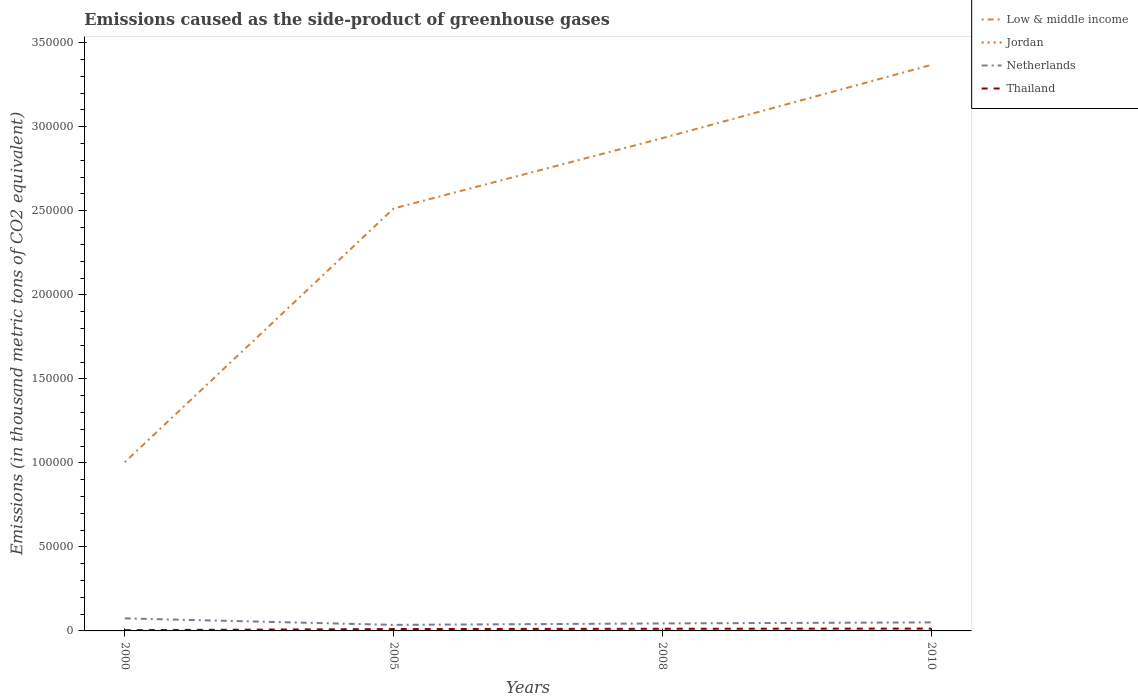Does the line corresponding to Jordan intersect with the line corresponding to Low & middle income?
Your answer should be very brief. No. Is the number of lines equal to the number of legend labels?
Provide a short and direct response. Yes. Across all years, what is the maximum emissions caused as the side-product of greenhouse gases in Low & middle income?
Your response must be concise. 1.00e+05. In which year was the emissions caused as the side-product of greenhouse gases in Netherlands maximum?
Your response must be concise. 2005. What is the total emissions caused as the side-product of greenhouse gases in Netherlands in the graph?
Offer a terse response. 3865.1. What is the difference between the highest and the second highest emissions caused as the side-product of greenhouse gases in Jordan?
Provide a short and direct response. 173.3. What is the difference between the highest and the lowest emissions caused as the side-product of greenhouse gases in Thailand?
Provide a succinct answer. 3. How many lines are there?
Keep it short and to the point. 4. What is the difference between two consecutive major ticks on the Y-axis?
Provide a short and direct response. 5.00e+04. Does the graph contain grids?
Your answer should be very brief. No. Where does the legend appear in the graph?
Ensure brevity in your answer.  Top right. How many legend labels are there?
Ensure brevity in your answer.  4. How are the legend labels stacked?
Keep it short and to the point. Vertical. What is the title of the graph?
Offer a very short reply. Emissions caused as the side-product of greenhouse gases. What is the label or title of the Y-axis?
Keep it short and to the point. Emissions (in thousand metric tons of CO2 equivalent). What is the Emissions (in thousand metric tons of CO2 equivalent) of Low & middle income in 2000?
Provide a short and direct response. 1.00e+05. What is the Emissions (in thousand metric tons of CO2 equivalent) in Netherlands in 2000?
Your answer should be very brief. 7462.9. What is the Emissions (in thousand metric tons of CO2 equivalent) in Thailand in 2000?
Your answer should be very brief. 453.1. What is the Emissions (in thousand metric tons of CO2 equivalent) of Low & middle income in 2005?
Provide a succinct answer. 2.51e+05. What is the Emissions (in thousand metric tons of CO2 equivalent) in Jordan in 2005?
Your answer should be compact. 110.3. What is the Emissions (in thousand metric tons of CO2 equivalent) of Netherlands in 2005?
Your response must be concise. 3597.8. What is the Emissions (in thousand metric tons of CO2 equivalent) of Thailand in 2005?
Your response must be concise. 1103.9. What is the Emissions (in thousand metric tons of CO2 equivalent) of Low & middle income in 2008?
Provide a short and direct response. 2.93e+05. What is the Emissions (in thousand metric tons of CO2 equivalent) of Jordan in 2008?
Your answer should be compact. 158.8. What is the Emissions (in thousand metric tons of CO2 equivalent) in Netherlands in 2008?
Provide a succinct answer. 4459.4. What is the Emissions (in thousand metric tons of CO2 equivalent) of Thailand in 2008?
Offer a terse response. 1274.5. What is the Emissions (in thousand metric tons of CO2 equivalent) in Low & middle income in 2010?
Offer a very short reply. 3.37e+05. What is the Emissions (in thousand metric tons of CO2 equivalent) of Jordan in 2010?
Provide a short and direct response. 193. What is the Emissions (in thousand metric tons of CO2 equivalent) of Netherlands in 2010?
Offer a terse response. 5074. What is the Emissions (in thousand metric tons of CO2 equivalent) in Thailand in 2010?
Make the answer very short. 1388. Across all years, what is the maximum Emissions (in thousand metric tons of CO2 equivalent) of Low & middle income?
Ensure brevity in your answer.  3.37e+05. Across all years, what is the maximum Emissions (in thousand metric tons of CO2 equivalent) in Jordan?
Give a very brief answer. 193. Across all years, what is the maximum Emissions (in thousand metric tons of CO2 equivalent) of Netherlands?
Offer a terse response. 7462.9. Across all years, what is the maximum Emissions (in thousand metric tons of CO2 equivalent) in Thailand?
Ensure brevity in your answer.  1388. Across all years, what is the minimum Emissions (in thousand metric tons of CO2 equivalent) in Low & middle income?
Your answer should be compact. 1.00e+05. Across all years, what is the minimum Emissions (in thousand metric tons of CO2 equivalent) in Netherlands?
Your answer should be compact. 3597.8. Across all years, what is the minimum Emissions (in thousand metric tons of CO2 equivalent) in Thailand?
Offer a very short reply. 453.1. What is the total Emissions (in thousand metric tons of CO2 equivalent) in Low & middle income in the graph?
Keep it short and to the point. 9.82e+05. What is the total Emissions (in thousand metric tons of CO2 equivalent) in Jordan in the graph?
Your answer should be very brief. 481.8. What is the total Emissions (in thousand metric tons of CO2 equivalent) in Netherlands in the graph?
Make the answer very short. 2.06e+04. What is the total Emissions (in thousand metric tons of CO2 equivalent) of Thailand in the graph?
Your answer should be very brief. 4219.5. What is the difference between the Emissions (in thousand metric tons of CO2 equivalent) in Low & middle income in 2000 and that in 2005?
Ensure brevity in your answer.  -1.51e+05. What is the difference between the Emissions (in thousand metric tons of CO2 equivalent) of Jordan in 2000 and that in 2005?
Keep it short and to the point. -90.6. What is the difference between the Emissions (in thousand metric tons of CO2 equivalent) in Netherlands in 2000 and that in 2005?
Your answer should be compact. 3865.1. What is the difference between the Emissions (in thousand metric tons of CO2 equivalent) in Thailand in 2000 and that in 2005?
Ensure brevity in your answer.  -650.8. What is the difference between the Emissions (in thousand metric tons of CO2 equivalent) in Low & middle income in 2000 and that in 2008?
Offer a very short reply. -1.93e+05. What is the difference between the Emissions (in thousand metric tons of CO2 equivalent) in Jordan in 2000 and that in 2008?
Offer a terse response. -139.1. What is the difference between the Emissions (in thousand metric tons of CO2 equivalent) in Netherlands in 2000 and that in 2008?
Your answer should be compact. 3003.5. What is the difference between the Emissions (in thousand metric tons of CO2 equivalent) in Thailand in 2000 and that in 2008?
Ensure brevity in your answer.  -821.4. What is the difference between the Emissions (in thousand metric tons of CO2 equivalent) of Low & middle income in 2000 and that in 2010?
Your response must be concise. -2.36e+05. What is the difference between the Emissions (in thousand metric tons of CO2 equivalent) in Jordan in 2000 and that in 2010?
Your answer should be compact. -173.3. What is the difference between the Emissions (in thousand metric tons of CO2 equivalent) in Netherlands in 2000 and that in 2010?
Offer a terse response. 2388.9. What is the difference between the Emissions (in thousand metric tons of CO2 equivalent) in Thailand in 2000 and that in 2010?
Give a very brief answer. -934.9. What is the difference between the Emissions (in thousand metric tons of CO2 equivalent) in Low & middle income in 2005 and that in 2008?
Ensure brevity in your answer.  -4.19e+04. What is the difference between the Emissions (in thousand metric tons of CO2 equivalent) in Jordan in 2005 and that in 2008?
Your answer should be very brief. -48.5. What is the difference between the Emissions (in thousand metric tons of CO2 equivalent) in Netherlands in 2005 and that in 2008?
Ensure brevity in your answer.  -861.6. What is the difference between the Emissions (in thousand metric tons of CO2 equivalent) in Thailand in 2005 and that in 2008?
Make the answer very short. -170.6. What is the difference between the Emissions (in thousand metric tons of CO2 equivalent) of Low & middle income in 2005 and that in 2010?
Provide a succinct answer. -8.55e+04. What is the difference between the Emissions (in thousand metric tons of CO2 equivalent) of Jordan in 2005 and that in 2010?
Your response must be concise. -82.7. What is the difference between the Emissions (in thousand metric tons of CO2 equivalent) of Netherlands in 2005 and that in 2010?
Make the answer very short. -1476.2. What is the difference between the Emissions (in thousand metric tons of CO2 equivalent) in Thailand in 2005 and that in 2010?
Make the answer very short. -284.1. What is the difference between the Emissions (in thousand metric tons of CO2 equivalent) in Low & middle income in 2008 and that in 2010?
Offer a terse response. -4.36e+04. What is the difference between the Emissions (in thousand metric tons of CO2 equivalent) of Jordan in 2008 and that in 2010?
Your answer should be very brief. -34.2. What is the difference between the Emissions (in thousand metric tons of CO2 equivalent) in Netherlands in 2008 and that in 2010?
Your answer should be very brief. -614.6. What is the difference between the Emissions (in thousand metric tons of CO2 equivalent) of Thailand in 2008 and that in 2010?
Offer a terse response. -113.5. What is the difference between the Emissions (in thousand metric tons of CO2 equivalent) in Low & middle income in 2000 and the Emissions (in thousand metric tons of CO2 equivalent) in Jordan in 2005?
Offer a terse response. 1.00e+05. What is the difference between the Emissions (in thousand metric tons of CO2 equivalent) in Low & middle income in 2000 and the Emissions (in thousand metric tons of CO2 equivalent) in Netherlands in 2005?
Keep it short and to the point. 9.68e+04. What is the difference between the Emissions (in thousand metric tons of CO2 equivalent) in Low & middle income in 2000 and the Emissions (in thousand metric tons of CO2 equivalent) in Thailand in 2005?
Ensure brevity in your answer.  9.93e+04. What is the difference between the Emissions (in thousand metric tons of CO2 equivalent) of Jordan in 2000 and the Emissions (in thousand metric tons of CO2 equivalent) of Netherlands in 2005?
Give a very brief answer. -3578.1. What is the difference between the Emissions (in thousand metric tons of CO2 equivalent) in Jordan in 2000 and the Emissions (in thousand metric tons of CO2 equivalent) in Thailand in 2005?
Offer a very short reply. -1084.2. What is the difference between the Emissions (in thousand metric tons of CO2 equivalent) of Netherlands in 2000 and the Emissions (in thousand metric tons of CO2 equivalent) of Thailand in 2005?
Offer a very short reply. 6359. What is the difference between the Emissions (in thousand metric tons of CO2 equivalent) of Low & middle income in 2000 and the Emissions (in thousand metric tons of CO2 equivalent) of Jordan in 2008?
Your answer should be very brief. 1.00e+05. What is the difference between the Emissions (in thousand metric tons of CO2 equivalent) of Low & middle income in 2000 and the Emissions (in thousand metric tons of CO2 equivalent) of Netherlands in 2008?
Offer a terse response. 9.59e+04. What is the difference between the Emissions (in thousand metric tons of CO2 equivalent) of Low & middle income in 2000 and the Emissions (in thousand metric tons of CO2 equivalent) of Thailand in 2008?
Your answer should be very brief. 9.91e+04. What is the difference between the Emissions (in thousand metric tons of CO2 equivalent) in Jordan in 2000 and the Emissions (in thousand metric tons of CO2 equivalent) in Netherlands in 2008?
Give a very brief answer. -4439.7. What is the difference between the Emissions (in thousand metric tons of CO2 equivalent) of Jordan in 2000 and the Emissions (in thousand metric tons of CO2 equivalent) of Thailand in 2008?
Ensure brevity in your answer.  -1254.8. What is the difference between the Emissions (in thousand metric tons of CO2 equivalent) of Netherlands in 2000 and the Emissions (in thousand metric tons of CO2 equivalent) of Thailand in 2008?
Offer a terse response. 6188.4. What is the difference between the Emissions (in thousand metric tons of CO2 equivalent) in Low & middle income in 2000 and the Emissions (in thousand metric tons of CO2 equivalent) in Jordan in 2010?
Your answer should be very brief. 1.00e+05. What is the difference between the Emissions (in thousand metric tons of CO2 equivalent) in Low & middle income in 2000 and the Emissions (in thousand metric tons of CO2 equivalent) in Netherlands in 2010?
Your answer should be compact. 9.53e+04. What is the difference between the Emissions (in thousand metric tons of CO2 equivalent) in Low & middle income in 2000 and the Emissions (in thousand metric tons of CO2 equivalent) in Thailand in 2010?
Your answer should be very brief. 9.90e+04. What is the difference between the Emissions (in thousand metric tons of CO2 equivalent) of Jordan in 2000 and the Emissions (in thousand metric tons of CO2 equivalent) of Netherlands in 2010?
Keep it short and to the point. -5054.3. What is the difference between the Emissions (in thousand metric tons of CO2 equivalent) of Jordan in 2000 and the Emissions (in thousand metric tons of CO2 equivalent) of Thailand in 2010?
Provide a succinct answer. -1368.3. What is the difference between the Emissions (in thousand metric tons of CO2 equivalent) in Netherlands in 2000 and the Emissions (in thousand metric tons of CO2 equivalent) in Thailand in 2010?
Provide a short and direct response. 6074.9. What is the difference between the Emissions (in thousand metric tons of CO2 equivalent) of Low & middle income in 2005 and the Emissions (in thousand metric tons of CO2 equivalent) of Jordan in 2008?
Your answer should be very brief. 2.51e+05. What is the difference between the Emissions (in thousand metric tons of CO2 equivalent) in Low & middle income in 2005 and the Emissions (in thousand metric tons of CO2 equivalent) in Netherlands in 2008?
Provide a short and direct response. 2.47e+05. What is the difference between the Emissions (in thousand metric tons of CO2 equivalent) of Low & middle income in 2005 and the Emissions (in thousand metric tons of CO2 equivalent) of Thailand in 2008?
Ensure brevity in your answer.  2.50e+05. What is the difference between the Emissions (in thousand metric tons of CO2 equivalent) of Jordan in 2005 and the Emissions (in thousand metric tons of CO2 equivalent) of Netherlands in 2008?
Offer a terse response. -4349.1. What is the difference between the Emissions (in thousand metric tons of CO2 equivalent) in Jordan in 2005 and the Emissions (in thousand metric tons of CO2 equivalent) in Thailand in 2008?
Your answer should be compact. -1164.2. What is the difference between the Emissions (in thousand metric tons of CO2 equivalent) of Netherlands in 2005 and the Emissions (in thousand metric tons of CO2 equivalent) of Thailand in 2008?
Your answer should be very brief. 2323.3. What is the difference between the Emissions (in thousand metric tons of CO2 equivalent) of Low & middle income in 2005 and the Emissions (in thousand metric tons of CO2 equivalent) of Jordan in 2010?
Your response must be concise. 2.51e+05. What is the difference between the Emissions (in thousand metric tons of CO2 equivalent) of Low & middle income in 2005 and the Emissions (in thousand metric tons of CO2 equivalent) of Netherlands in 2010?
Your response must be concise. 2.46e+05. What is the difference between the Emissions (in thousand metric tons of CO2 equivalent) in Low & middle income in 2005 and the Emissions (in thousand metric tons of CO2 equivalent) in Thailand in 2010?
Keep it short and to the point. 2.50e+05. What is the difference between the Emissions (in thousand metric tons of CO2 equivalent) of Jordan in 2005 and the Emissions (in thousand metric tons of CO2 equivalent) of Netherlands in 2010?
Your response must be concise. -4963.7. What is the difference between the Emissions (in thousand metric tons of CO2 equivalent) of Jordan in 2005 and the Emissions (in thousand metric tons of CO2 equivalent) of Thailand in 2010?
Ensure brevity in your answer.  -1277.7. What is the difference between the Emissions (in thousand metric tons of CO2 equivalent) of Netherlands in 2005 and the Emissions (in thousand metric tons of CO2 equivalent) of Thailand in 2010?
Offer a terse response. 2209.8. What is the difference between the Emissions (in thousand metric tons of CO2 equivalent) in Low & middle income in 2008 and the Emissions (in thousand metric tons of CO2 equivalent) in Jordan in 2010?
Provide a succinct answer. 2.93e+05. What is the difference between the Emissions (in thousand metric tons of CO2 equivalent) in Low & middle income in 2008 and the Emissions (in thousand metric tons of CO2 equivalent) in Netherlands in 2010?
Give a very brief answer. 2.88e+05. What is the difference between the Emissions (in thousand metric tons of CO2 equivalent) in Low & middle income in 2008 and the Emissions (in thousand metric tons of CO2 equivalent) in Thailand in 2010?
Make the answer very short. 2.92e+05. What is the difference between the Emissions (in thousand metric tons of CO2 equivalent) in Jordan in 2008 and the Emissions (in thousand metric tons of CO2 equivalent) in Netherlands in 2010?
Ensure brevity in your answer.  -4915.2. What is the difference between the Emissions (in thousand metric tons of CO2 equivalent) in Jordan in 2008 and the Emissions (in thousand metric tons of CO2 equivalent) in Thailand in 2010?
Your response must be concise. -1229.2. What is the difference between the Emissions (in thousand metric tons of CO2 equivalent) in Netherlands in 2008 and the Emissions (in thousand metric tons of CO2 equivalent) in Thailand in 2010?
Provide a short and direct response. 3071.4. What is the average Emissions (in thousand metric tons of CO2 equivalent) of Low & middle income per year?
Ensure brevity in your answer.  2.45e+05. What is the average Emissions (in thousand metric tons of CO2 equivalent) of Jordan per year?
Provide a succinct answer. 120.45. What is the average Emissions (in thousand metric tons of CO2 equivalent) in Netherlands per year?
Keep it short and to the point. 5148.52. What is the average Emissions (in thousand metric tons of CO2 equivalent) in Thailand per year?
Your answer should be very brief. 1054.88. In the year 2000, what is the difference between the Emissions (in thousand metric tons of CO2 equivalent) of Low & middle income and Emissions (in thousand metric tons of CO2 equivalent) of Jordan?
Offer a very short reply. 1.00e+05. In the year 2000, what is the difference between the Emissions (in thousand metric tons of CO2 equivalent) in Low & middle income and Emissions (in thousand metric tons of CO2 equivalent) in Netherlands?
Make the answer very short. 9.29e+04. In the year 2000, what is the difference between the Emissions (in thousand metric tons of CO2 equivalent) in Low & middle income and Emissions (in thousand metric tons of CO2 equivalent) in Thailand?
Give a very brief answer. 1.00e+05. In the year 2000, what is the difference between the Emissions (in thousand metric tons of CO2 equivalent) in Jordan and Emissions (in thousand metric tons of CO2 equivalent) in Netherlands?
Offer a terse response. -7443.2. In the year 2000, what is the difference between the Emissions (in thousand metric tons of CO2 equivalent) of Jordan and Emissions (in thousand metric tons of CO2 equivalent) of Thailand?
Provide a short and direct response. -433.4. In the year 2000, what is the difference between the Emissions (in thousand metric tons of CO2 equivalent) in Netherlands and Emissions (in thousand metric tons of CO2 equivalent) in Thailand?
Provide a succinct answer. 7009.8. In the year 2005, what is the difference between the Emissions (in thousand metric tons of CO2 equivalent) in Low & middle income and Emissions (in thousand metric tons of CO2 equivalent) in Jordan?
Make the answer very short. 2.51e+05. In the year 2005, what is the difference between the Emissions (in thousand metric tons of CO2 equivalent) of Low & middle income and Emissions (in thousand metric tons of CO2 equivalent) of Netherlands?
Keep it short and to the point. 2.48e+05. In the year 2005, what is the difference between the Emissions (in thousand metric tons of CO2 equivalent) in Low & middle income and Emissions (in thousand metric tons of CO2 equivalent) in Thailand?
Your answer should be very brief. 2.50e+05. In the year 2005, what is the difference between the Emissions (in thousand metric tons of CO2 equivalent) in Jordan and Emissions (in thousand metric tons of CO2 equivalent) in Netherlands?
Your response must be concise. -3487.5. In the year 2005, what is the difference between the Emissions (in thousand metric tons of CO2 equivalent) of Jordan and Emissions (in thousand metric tons of CO2 equivalent) of Thailand?
Keep it short and to the point. -993.6. In the year 2005, what is the difference between the Emissions (in thousand metric tons of CO2 equivalent) of Netherlands and Emissions (in thousand metric tons of CO2 equivalent) of Thailand?
Offer a very short reply. 2493.9. In the year 2008, what is the difference between the Emissions (in thousand metric tons of CO2 equivalent) of Low & middle income and Emissions (in thousand metric tons of CO2 equivalent) of Jordan?
Offer a terse response. 2.93e+05. In the year 2008, what is the difference between the Emissions (in thousand metric tons of CO2 equivalent) in Low & middle income and Emissions (in thousand metric tons of CO2 equivalent) in Netherlands?
Your response must be concise. 2.89e+05. In the year 2008, what is the difference between the Emissions (in thousand metric tons of CO2 equivalent) of Low & middle income and Emissions (in thousand metric tons of CO2 equivalent) of Thailand?
Your answer should be compact. 2.92e+05. In the year 2008, what is the difference between the Emissions (in thousand metric tons of CO2 equivalent) in Jordan and Emissions (in thousand metric tons of CO2 equivalent) in Netherlands?
Your answer should be very brief. -4300.6. In the year 2008, what is the difference between the Emissions (in thousand metric tons of CO2 equivalent) of Jordan and Emissions (in thousand metric tons of CO2 equivalent) of Thailand?
Your answer should be very brief. -1115.7. In the year 2008, what is the difference between the Emissions (in thousand metric tons of CO2 equivalent) of Netherlands and Emissions (in thousand metric tons of CO2 equivalent) of Thailand?
Give a very brief answer. 3184.9. In the year 2010, what is the difference between the Emissions (in thousand metric tons of CO2 equivalent) in Low & middle income and Emissions (in thousand metric tons of CO2 equivalent) in Jordan?
Provide a succinct answer. 3.37e+05. In the year 2010, what is the difference between the Emissions (in thousand metric tons of CO2 equivalent) of Low & middle income and Emissions (in thousand metric tons of CO2 equivalent) of Netherlands?
Your response must be concise. 3.32e+05. In the year 2010, what is the difference between the Emissions (in thousand metric tons of CO2 equivalent) in Low & middle income and Emissions (in thousand metric tons of CO2 equivalent) in Thailand?
Ensure brevity in your answer.  3.35e+05. In the year 2010, what is the difference between the Emissions (in thousand metric tons of CO2 equivalent) in Jordan and Emissions (in thousand metric tons of CO2 equivalent) in Netherlands?
Give a very brief answer. -4881. In the year 2010, what is the difference between the Emissions (in thousand metric tons of CO2 equivalent) of Jordan and Emissions (in thousand metric tons of CO2 equivalent) of Thailand?
Offer a terse response. -1195. In the year 2010, what is the difference between the Emissions (in thousand metric tons of CO2 equivalent) of Netherlands and Emissions (in thousand metric tons of CO2 equivalent) of Thailand?
Your answer should be compact. 3686. What is the ratio of the Emissions (in thousand metric tons of CO2 equivalent) in Low & middle income in 2000 to that in 2005?
Your answer should be compact. 0.4. What is the ratio of the Emissions (in thousand metric tons of CO2 equivalent) of Jordan in 2000 to that in 2005?
Keep it short and to the point. 0.18. What is the ratio of the Emissions (in thousand metric tons of CO2 equivalent) of Netherlands in 2000 to that in 2005?
Provide a succinct answer. 2.07. What is the ratio of the Emissions (in thousand metric tons of CO2 equivalent) in Thailand in 2000 to that in 2005?
Offer a terse response. 0.41. What is the ratio of the Emissions (in thousand metric tons of CO2 equivalent) of Low & middle income in 2000 to that in 2008?
Provide a short and direct response. 0.34. What is the ratio of the Emissions (in thousand metric tons of CO2 equivalent) in Jordan in 2000 to that in 2008?
Offer a terse response. 0.12. What is the ratio of the Emissions (in thousand metric tons of CO2 equivalent) of Netherlands in 2000 to that in 2008?
Ensure brevity in your answer.  1.67. What is the ratio of the Emissions (in thousand metric tons of CO2 equivalent) of Thailand in 2000 to that in 2008?
Keep it short and to the point. 0.36. What is the ratio of the Emissions (in thousand metric tons of CO2 equivalent) in Low & middle income in 2000 to that in 2010?
Your answer should be very brief. 0.3. What is the ratio of the Emissions (in thousand metric tons of CO2 equivalent) in Jordan in 2000 to that in 2010?
Your response must be concise. 0.1. What is the ratio of the Emissions (in thousand metric tons of CO2 equivalent) in Netherlands in 2000 to that in 2010?
Your response must be concise. 1.47. What is the ratio of the Emissions (in thousand metric tons of CO2 equivalent) of Thailand in 2000 to that in 2010?
Offer a terse response. 0.33. What is the ratio of the Emissions (in thousand metric tons of CO2 equivalent) of Low & middle income in 2005 to that in 2008?
Ensure brevity in your answer.  0.86. What is the ratio of the Emissions (in thousand metric tons of CO2 equivalent) of Jordan in 2005 to that in 2008?
Give a very brief answer. 0.69. What is the ratio of the Emissions (in thousand metric tons of CO2 equivalent) of Netherlands in 2005 to that in 2008?
Provide a short and direct response. 0.81. What is the ratio of the Emissions (in thousand metric tons of CO2 equivalent) of Thailand in 2005 to that in 2008?
Your answer should be very brief. 0.87. What is the ratio of the Emissions (in thousand metric tons of CO2 equivalent) of Low & middle income in 2005 to that in 2010?
Give a very brief answer. 0.75. What is the ratio of the Emissions (in thousand metric tons of CO2 equivalent) in Jordan in 2005 to that in 2010?
Ensure brevity in your answer.  0.57. What is the ratio of the Emissions (in thousand metric tons of CO2 equivalent) of Netherlands in 2005 to that in 2010?
Give a very brief answer. 0.71. What is the ratio of the Emissions (in thousand metric tons of CO2 equivalent) of Thailand in 2005 to that in 2010?
Keep it short and to the point. 0.8. What is the ratio of the Emissions (in thousand metric tons of CO2 equivalent) of Low & middle income in 2008 to that in 2010?
Keep it short and to the point. 0.87. What is the ratio of the Emissions (in thousand metric tons of CO2 equivalent) in Jordan in 2008 to that in 2010?
Your answer should be compact. 0.82. What is the ratio of the Emissions (in thousand metric tons of CO2 equivalent) in Netherlands in 2008 to that in 2010?
Make the answer very short. 0.88. What is the ratio of the Emissions (in thousand metric tons of CO2 equivalent) of Thailand in 2008 to that in 2010?
Keep it short and to the point. 0.92. What is the difference between the highest and the second highest Emissions (in thousand metric tons of CO2 equivalent) in Low & middle income?
Make the answer very short. 4.36e+04. What is the difference between the highest and the second highest Emissions (in thousand metric tons of CO2 equivalent) in Jordan?
Offer a very short reply. 34.2. What is the difference between the highest and the second highest Emissions (in thousand metric tons of CO2 equivalent) in Netherlands?
Ensure brevity in your answer.  2388.9. What is the difference between the highest and the second highest Emissions (in thousand metric tons of CO2 equivalent) in Thailand?
Your answer should be very brief. 113.5. What is the difference between the highest and the lowest Emissions (in thousand metric tons of CO2 equivalent) in Low & middle income?
Provide a short and direct response. 2.36e+05. What is the difference between the highest and the lowest Emissions (in thousand metric tons of CO2 equivalent) of Jordan?
Ensure brevity in your answer.  173.3. What is the difference between the highest and the lowest Emissions (in thousand metric tons of CO2 equivalent) in Netherlands?
Provide a succinct answer. 3865.1. What is the difference between the highest and the lowest Emissions (in thousand metric tons of CO2 equivalent) in Thailand?
Make the answer very short. 934.9. 